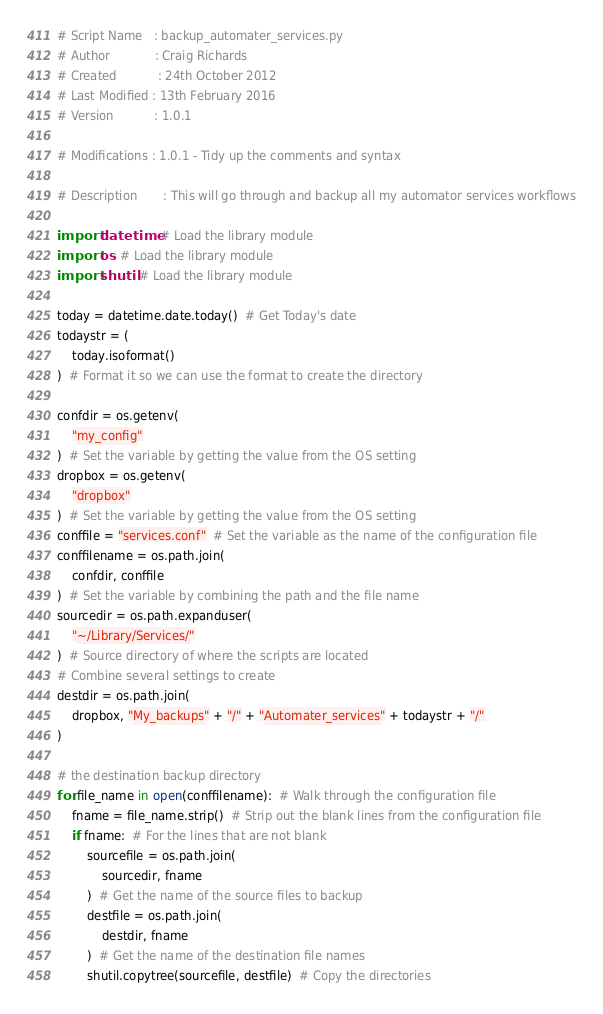<code> <loc_0><loc_0><loc_500><loc_500><_Python_># Script Name	: backup_automater_services.py
# Author			: Craig Richards
# Created			: 24th October 2012
# Last Modified	: 13th February 2016
# Version			: 1.0.1

# Modifications	: 1.0.1 - Tidy up the comments and syntax

# Description		: This will go through and backup all my automator services workflows

import datetime  # Load the library module
import os  # Load the library module
import shutil  # Load the library module

today = datetime.date.today()  # Get Today's date
todaystr = (
    today.isoformat()
)  # Format it so we can use the format to create the directory

confdir = os.getenv(
    "my_config"
)  # Set the variable by getting the value from the OS setting
dropbox = os.getenv(
    "dropbox"
)  # Set the variable by getting the value from the OS setting
conffile = "services.conf"  # Set the variable as the name of the configuration file
conffilename = os.path.join(
    confdir, conffile
)  # Set the variable by combining the path and the file name
sourcedir = os.path.expanduser(
    "~/Library/Services/"
)  # Source directory of where the scripts are located
# Combine several settings to create
destdir = os.path.join(
    dropbox, "My_backups" + "/" + "Automater_services" + todaystr + "/"
)

# the destination backup directory
for file_name in open(conffilename):  # Walk through the configuration file
    fname = file_name.strip()  # Strip out the blank lines from the configuration file
    if fname:  # For the lines that are not blank
        sourcefile = os.path.join(
            sourcedir, fname
        )  # Get the name of the source files to backup
        destfile = os.path.join(
            destdir, fname
        )  # Get the name of the destination file names
        shutil.copytree(sourcefile, destfile)  # Copy the directories
</code> 